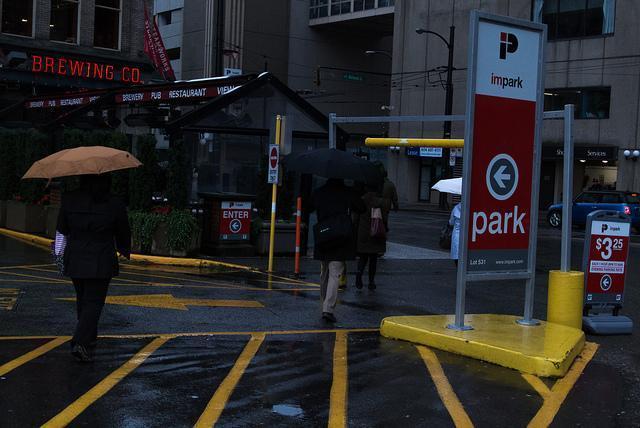How many people can you see?
Give a very brief answer. 3. How many umbrellas are in the photo?
Give a very brief answer. 2. 